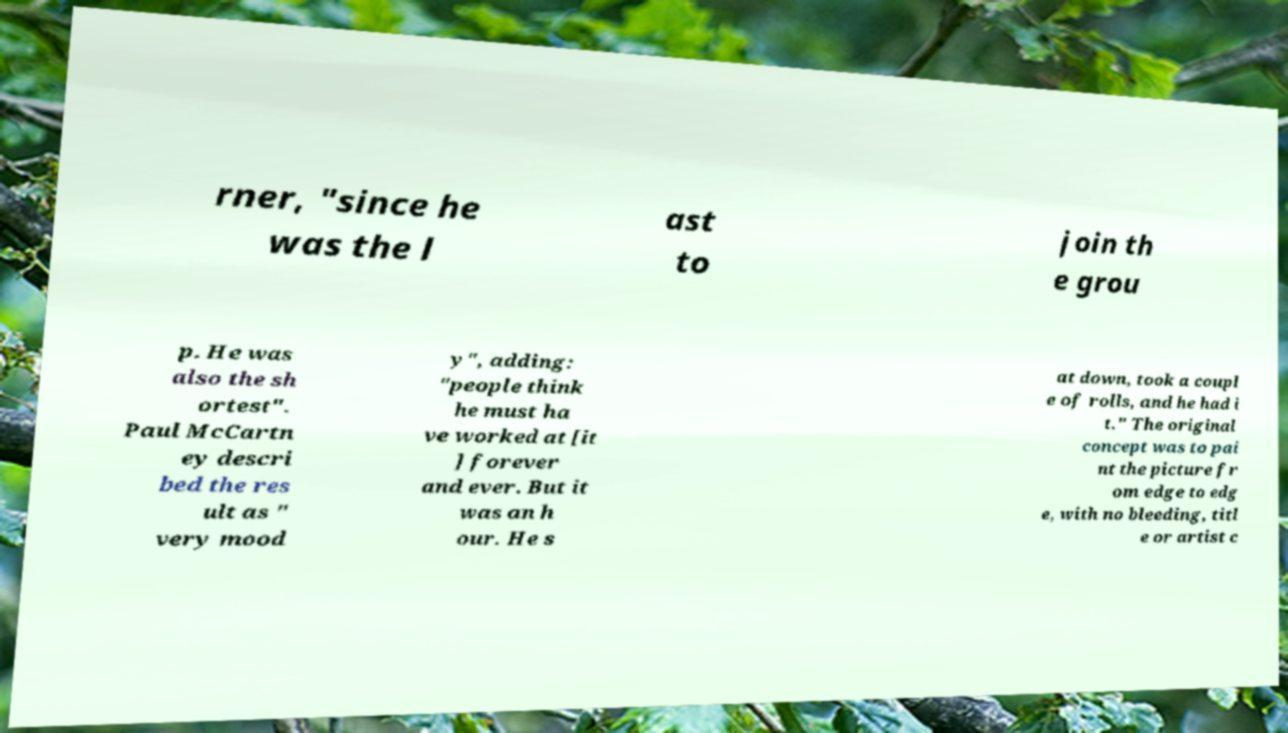Could you extract and type out the text from this image? rner, "since he was the l ast to join th e grou p. He was also the sh ortest". Paul McCartn ey descri bed the res ult as " very mood y", adding: "people think he must ha ve worked at [it ] forever and ever. But it was an h our. He s at down, took a coupl e of rolls, and he had i t." The original concept was to pai nt the picture fr om edge to edg e, with no bleeding, titl e or artist c 